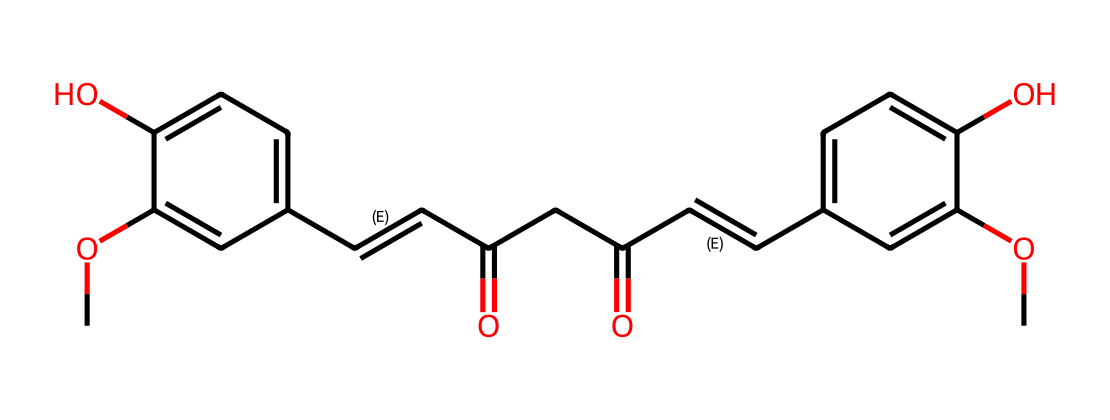What is the molecular formula of curcumin? By analyzing the structure represented by the SMILES notation, we can determine the total number of each type of atom present. The atoms included are carbon (C), hydrogen (H), and oxygen (O). Upon counting them, there are 21 carbon atoms, 20 hydrogen atoms, and 6 oxygen atoms, leading to the molecular formula C21H20O6.
Answer: C21H20O6 How many hydroxyl (–OH) groups are present in curcumin? Looking at the structural components, we identify two instances of –OH groups in the chemical structure. These groups are attached to aromatic rings within the molecule. Therefore, the total count is two.
Answer: 2 What type of chemical is curcumin classified as? Curcumin, based on its structure that contains phenolic groups along with conjugated double bonds, is classified as a polyphenol. This classification stems from the presence of multiple phenolic structures in its composition.
Answer: polyphenol What is the number of double bonds in the structure of curcumin? By examining the SMILES representation, we can identify the locations of all double bonds. There are three distinct instances of double bonds present in curcumin’s structure, which contribute to its overall chemical reactivity.
Answer: 3 Which functional groups are featured in curcumin's structure? In the chemical structure of curcumin, we see the presence of hydroxyl (–OH) groups and conjugated double bonds, along with carbonyl (C=O) groups. These functional groups play significant roles in curcumin's properties.
Answer: hydroxyl and carbonyl What is the role of the methoxy (–OCH3) groups in curcumin? The methoxy groups in curcumin provide both steric hindrance and electronic effects that influence its solubility and biological activity. They also contribute to the antioxidant capacity of the molecule.
Answer: solubility and antioxidant capacity 